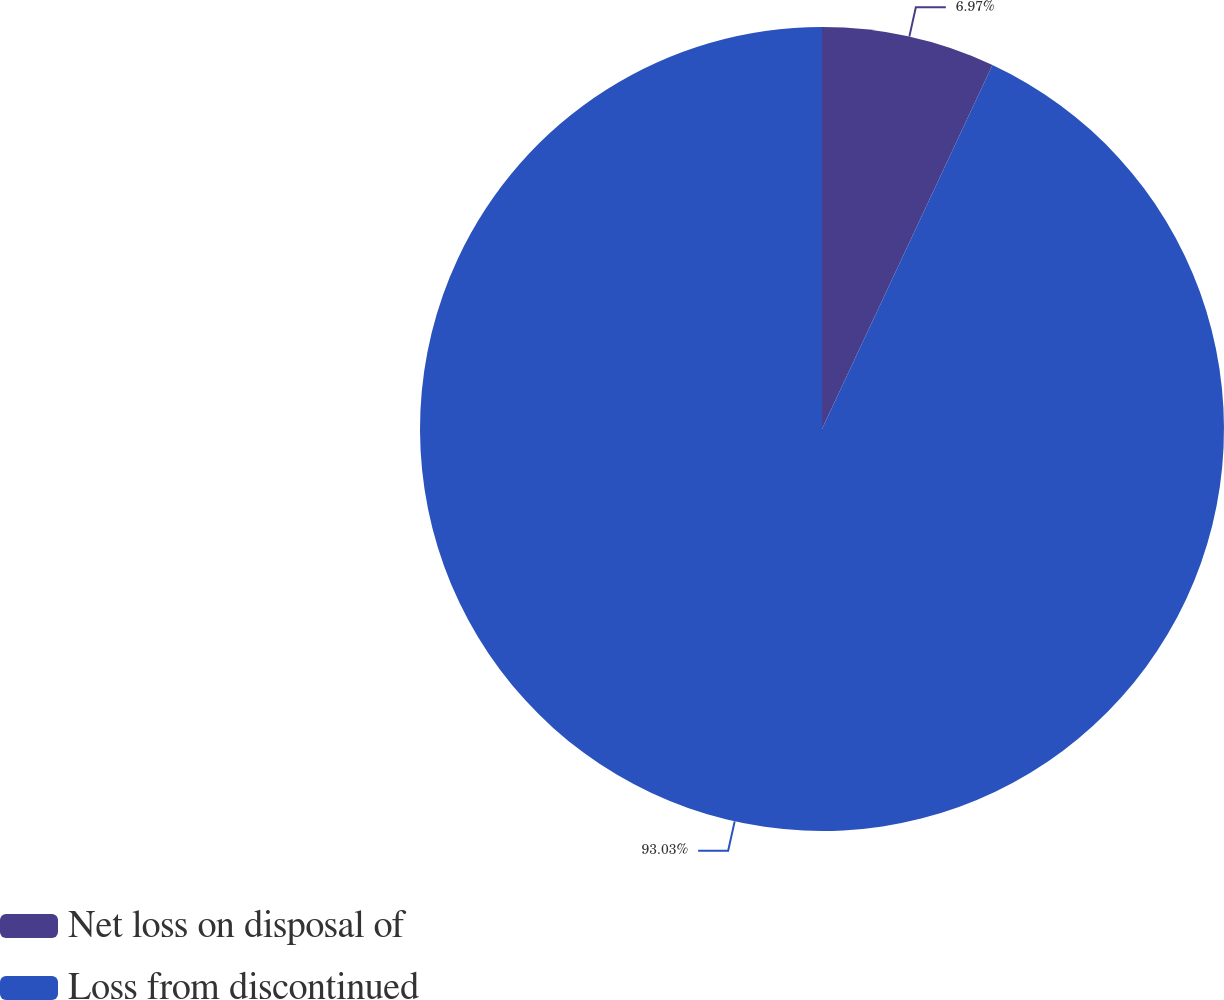<chart> <loc_0><loc_0><loc_500><loc_500><pie_chart><fcel>Net loss on disposal of<fcel>Loss from discontinued<nl><fcel>6.97%<fcel>93.03%<nl></chart> 